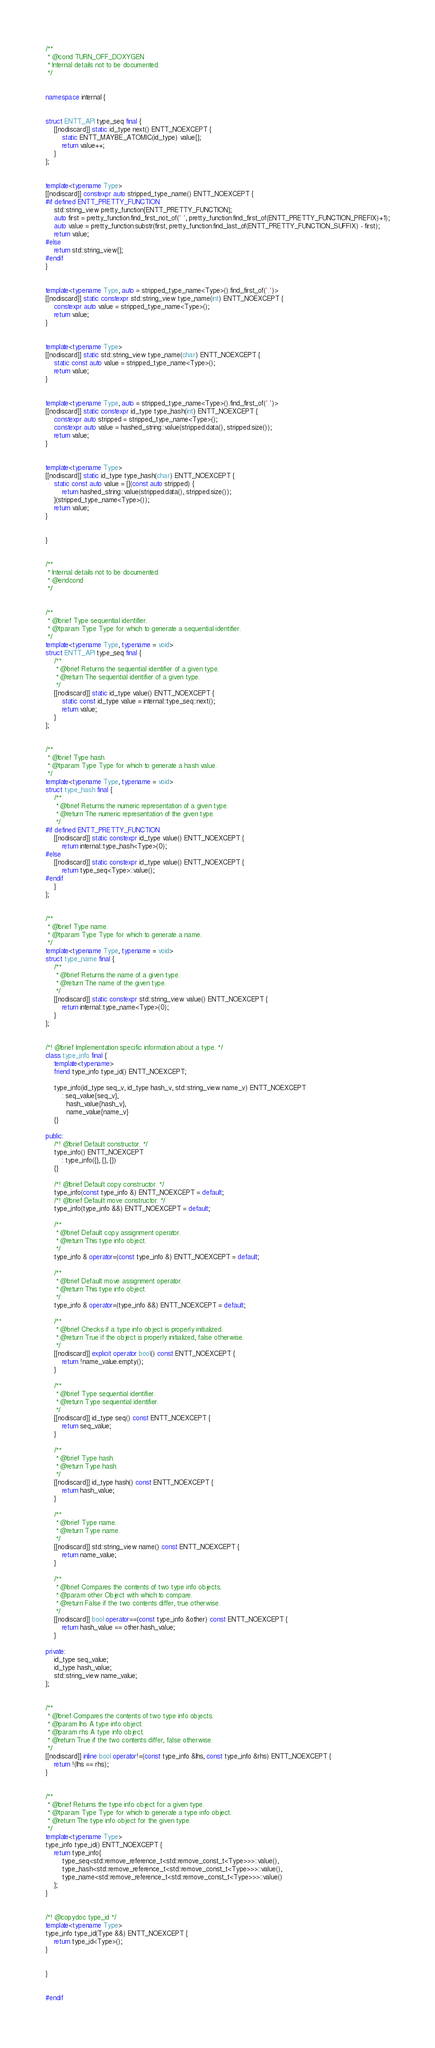Convert code to text. <code><loc_0><loc_0><loc_500><loc_500><_C++_>

/**
 * @cond TURN_OFF_DOXYGEN
 * Internal details not to be documented.
 */


namespace internal {


struct ENTT_API type_seq final {
    [[nodiscard]] static id_type next() ENTT_NOEXCEPT {
        static ENTT_MAYBE_ATOMIC(id_type) value{};
        return value++;
    }
};


template<typename Type>
[[nodiscard]] constexpr auto stripped_type_name() ENTT_NOEXCEPT {
#if defined ENTT_PRETTY_FUNCTION
    std::string_view pretty_function{ENTT_PRETTY_FUNCTION};
    auto first = pretty_function.find_first_not_of(' ', pretty_function.find_first_of(ENTT_PRETTY_FUNCTION_PREFIX)+1);
    auto value = pretty_function.substr(first, pretty_function.find_last_of(ENTT_PRETTY_FUNCTION_SUFFIX) - first);
    return value;
#else
    return std::string_view{};
#endif
}


template<typename Type, auto = stripped_type_name<Type>().find_first_of('.')>
[[nodiscard]] static constexpr std::string_view type_name(int) ENTT_NOEXCEPT {
    constexpr auto value = stripped_type_name<Type>();
    return value;
}


template<typename Type>
[[nodiscard]] static std::string_view type_name(char) ENTT_NOEXCEPT {
    static const auto value = stripped_type_name<Type>();
    return value;
}


template<typename Type, auto = stripped_type_name<Type>().find_first_of('.')>
[[nodiscard]] static constexpr id_type type_hash(int) ENTT_NOEXCEPT {
    constexpr auto stripped = stripped_type_name<Type>();
    constexpr auto value = hashed_string::value(stripped.data(), stripped.size());
    return value;
}


template<typename Type>
[[nodiscard]] static id_type type_hash(char) ENTT_NOEXCEPT {
    static const auto value = [](const auto stripped) {
        return hashed_string::value(stripped.data(), stripped.size());
    }(stripped_type_name<Type>());
    return value;
}


}


/**
 * Internal details not to be documented.
 * @endcond
 */


/**
 * @brief Type sequential identifier.
 * @tparam Type Type for which to generate a sequential identifier.
 */
template<typename Type, typename = void>
struct ENTT_API type_seq final {
    /**
     * @brief Returns the sequential identifier of a given type.
     * @return The sequential identifier of a given type.
     */
    [[nodiscard]] static id_type value() ENTT_NOEXCEPT {
        static const id_type value = internal::type_seq::next();
        return value;
    }
};


/**
 * @brief Type hash.
 * @tparam Type Type for which to generate a hash value.
 */
template<typename Type, typename = void>
struct type_hash final {
    /**
     * @brief Returns the numeric representation of a given type.
     * @return The numeric representation of the given type.
     */
#if defined ENTT_PRETTY_FUNCTION
    [[nodiscard]] static constexpr id_type value() ENTT_NOEXCEPT {
        return internal::type_hash<Type>(0);
#else
    [[nodiscard]] static constexpr id_type value() ENTT_NOEXCEPT {
        return type_seq<Type>::value();
#endif
    }
};


/**
 * @brief Type name.
 * @tparam Type Type for which to generate a name.
 */
template<typename Type, typename = void>
struct type_name final {
    /**
     * @brief Returns the name of a given type.
     * @return The name of the given type.
     */
    [[nodiscard]] static constexpr std::string_view value() ENTT_NOEXCEPT {
        return internal::type_name<Type>(0);
    }
};


/*! @brief Implementation specific information about a type. */
class type_info final {
    template<typename>
    friend type_info type_id() ENTT_NOEXCEPT;

    type_info(id_type seq_v, id_type hash_v, std::string_view name_v) ENTT_NOEXCEPT
        : seq_value{seq_v},
          hash_value{hash_v},
          name_value{name_v}
    {}

public:
    /*! @brief Default constructor. */
    type_info() ENTT_NOEXCEPT
        : type_info({}, {}, {})
    {}

    /*! @brief Default copy constructor. */
    type_info(const type_info &) ENTT_NOEXCEPT = default;
    /*! @brief Default move constructor. */
    type_info(type_info &&) ENTT_NOEXCEPT = default;

    /**
     * @brief Default copy assignment operator.
     * @return This type info object.
     */
    type_info & operator=(const type_info &) ENTT_NOEXCEPT = default;

    /**
     * @brief Default move assignment operator.
     * @return This type info object.
     */
    type_info & operator=(type_info &&) ENTT_NOEXCEPT = default;

    /**
     * @brief Checks if a type info object is properly initialized.
     * @return True if the object is properly initialized, false otherwise.
     */
    [[nodiscard]] explicit operator bool() const ENTT_NOEXCEPT {
        return !name_value.empty();
    }

    /**
     * @brief Type sequential identifier.
     * @return Type sequential identifier.
     */
    [[nodiscard]] id_type seq() const ENTT_NOEXCEPT {
        return seq_value;
    }

    /**
     * @brief Type hash.
     * @return Type hash.
     */
    [[nodiscard]] id_type hash() const ENTT_NOEXCEPT {
        return hash_value;
    }

    /**
     * @brief Type name.
     * @return Type name.
     */
    [[nodiscard]] std::string_view name() const ENTT_NOEXCEPT {
        return name_value;
    }

    /**
     * @brief Compares the contents of two type info objects.
     * @param other Object with which to compare.
     * @return False if the two contents differ, true otherwise.
     */
    [[nodiscard]] bool operator==(const type_info &other) const ENTT_NOEXCEPT {
        return hash_value == other.hash_value;
    }

private:
    id_type seq_value;
    id_type hash_value;
    std::string_view name_value;
};


/**
 * @brief Compares the contents of two type info objects.
 * @param lhs A type info object.
 * @param rhs A type info object.
 * @return True if the two contents differ, false otherwise.
 */
[[nodiscard]] inline bool operator!=(const type_info &lhs, const type_info &rhs) ENTT_NOEXCEPT {
    return !(lhs == rhs);
}


/**
 * @brief Returns the type info object for a given type.
 * @tparam Type Type for which to generate a type info object.
 * @return The type info object for the given type.
 */
template<typename Type>
type_info type_id() ENTT_NOEXCEPT {
    return type_info{
        type_seq<std::remove_reference_t<std::remove_const_t<Type>>>::value(),
        type_hash<std::remove_reference_t<std::remove_const_t<Type>>>::value(),
        type_name<std::remove_reference_t<std::remove_const_t<Type>>>::value()
    };
}


/*! @copydoc type_id */
template<typename Type>
type_info type_id(Type &&) ENTT_NOEXCEPT {
    return type_id<Type>();
}


}


#endif
</code> 